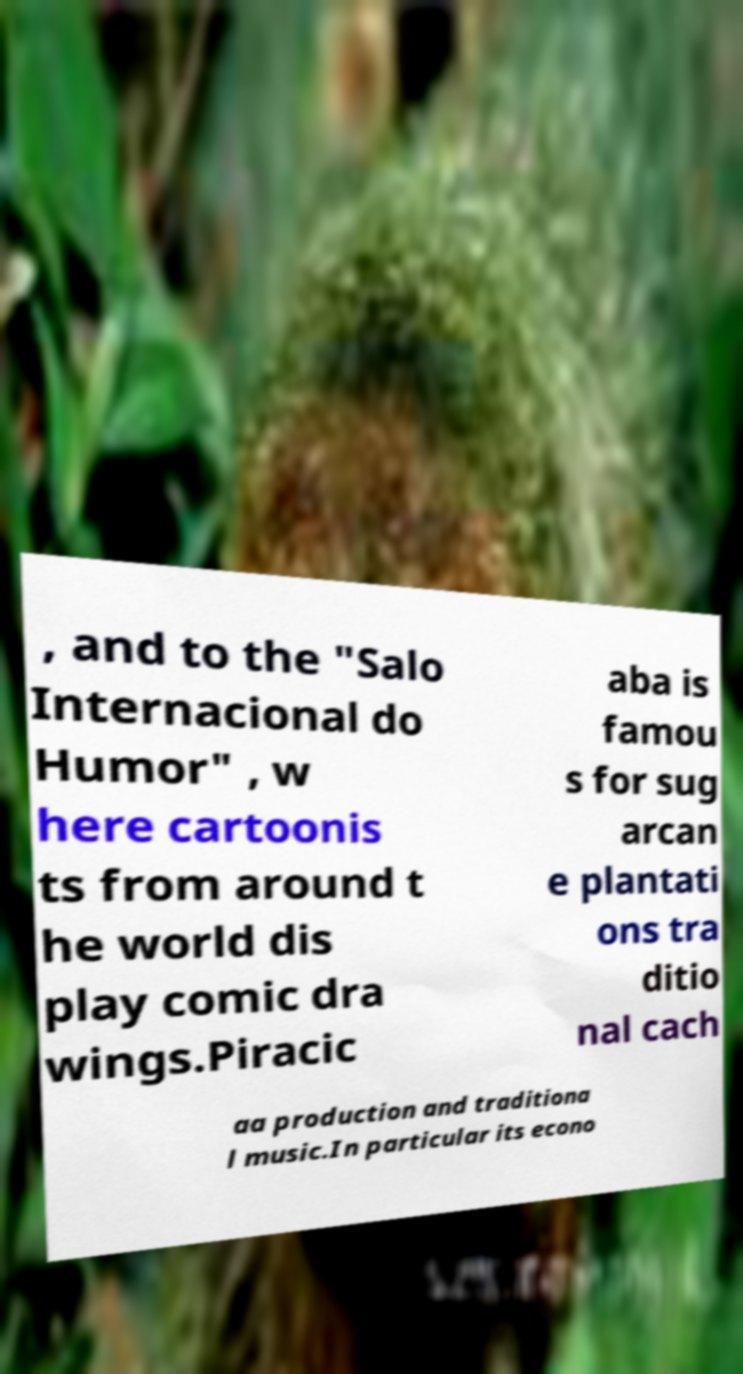For documentation purposes, I need the text within this image transcribed. Could you provide that? , and to the "Salo Internacional do Humor" , w here cartoonis ts from around t he world dis play comic dra wings.Piracic aba is famou s for sug arcan e plantati ons tra ditio nal cach aa production and traditiona l music.In particular its econo 